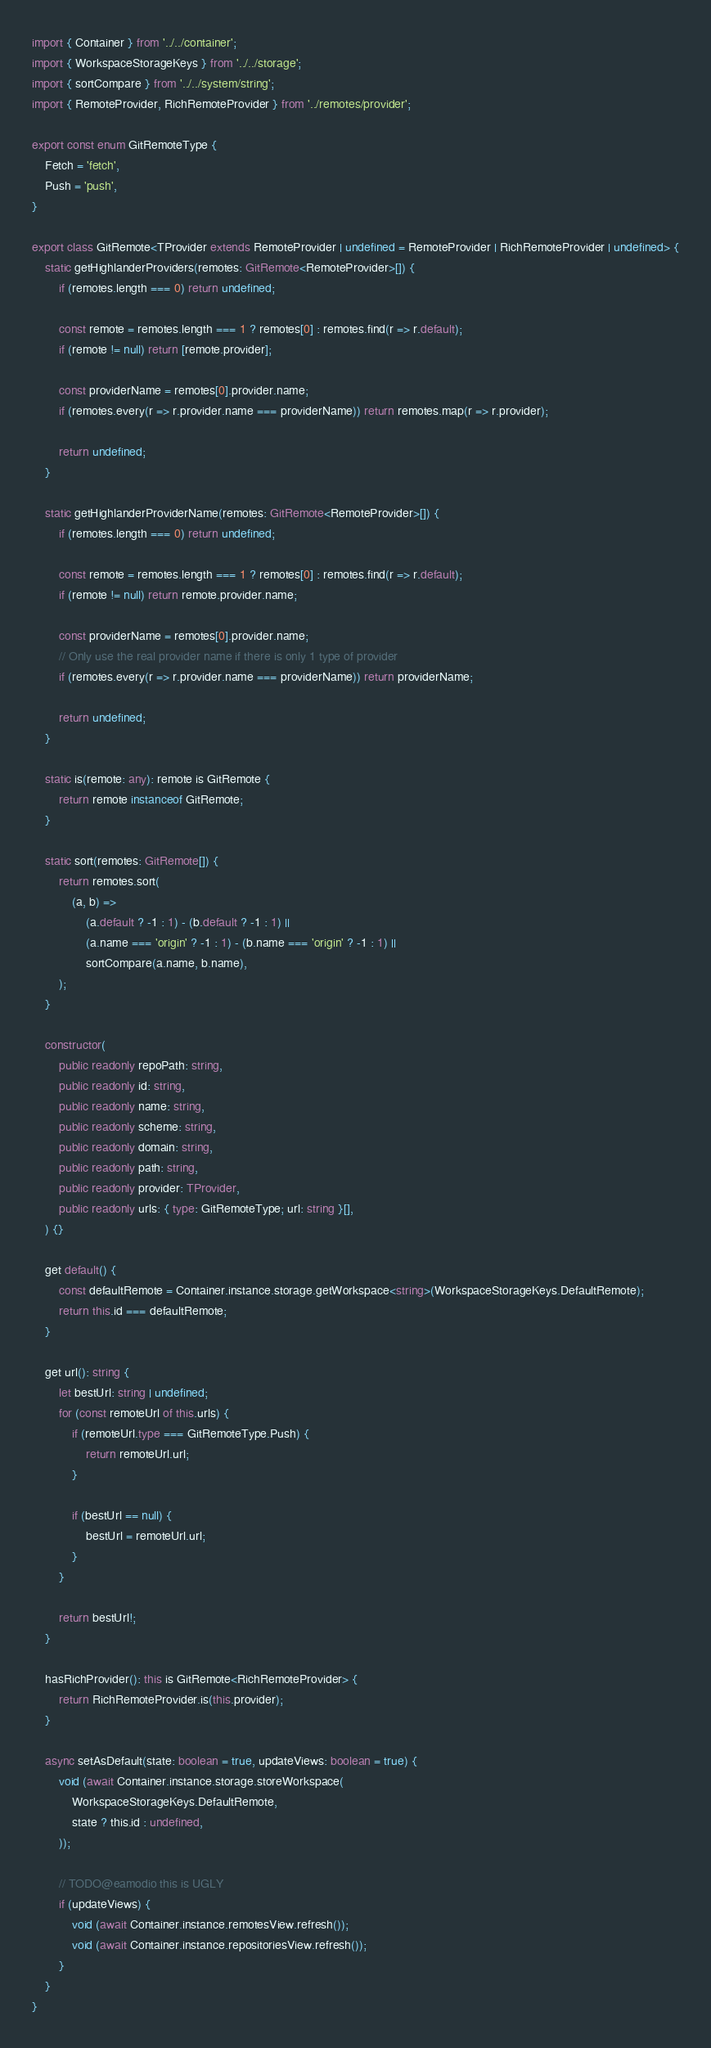Convert code to text. <code><loc_0><loc_0><loc_500><loc_500><_TypeScript_>import { Container } from '../../container';
import { WorkspaceStorageKeys } from '../../storage';
import { sortCompare } from '../../system/string';
import { RemoteProvider, RichRemoteProvider } from '../remotes/provider';

export const enum GitRemoteType {
	Fetch = 'fetch',
	Push = 'push',
}

export class GitRemote<TProvider extends RemoteProvider | undefined = RemoteProvider | RichRemoteProvider | undefined> {
	static getHighlanderProviders(remotes: GitRemote<RemoteProvider>[]) {
		if (remotes.length === 0) return undefined;

		const remote = remotes.length === 1 ? remotes[0] : remotes.find(r => r.default);
		if (remote != null) return [remote.provider];

		const providerName = remotes[0].provider.name;
		if (remotes.every(r => r.provider.name === providerName)) return remotes.map(r => r.provider);

		return undefined;
	}

	static getHighlanderProviderName(remotes: GitRemote<RemoteProvider>[]) {
		if (remotes.length === 0) return undefined;

		const remote = remotes.length === 1 ? remotes[0] : remotes.find(r => r.default);
		if (remote != null) return remote.provider.name;

		const providerName = remotes[0].provider.name;
		// Only use the real provider name if there is only 1 type of provider
		if (remotes.every(r => r.provider.name === providerName)) return providerName;

		return undefined;
	}

	static is(remote: any): remote is GitRemote {
		return remote instanceof GitRemote;
	}

	static sort(remotes: GitRemote[]) {
		return remotes.sort(
			(a, b) =>
				(a.default ? -1 : 1) - (b.default ? -1 : 1) ||
				(a.name === 'origin' ? -1 : 1) - (b.name === 'origin' ? -1 : 1) ||
				sortCompare(a.name, b.name),
		);
	}

	constructor(
		public readonly repoPath: string,
		public readonly id: string,
		public readonly name: string,
		public readonly scheme: string,
		public readonly domain: string,
		public readonly path: string,
		public readonly provider: TProvider,
		public readonly urls: { type: GitRemoteType; url: string }[],
	) {}

	get default() {
		const defaultRemote = Container.instance.storage.getWorkspace<string>(WorkspaceStorageKeys.DefaultRemote);
		return this.id === defaultRemote;
	}

	get url(): string {
		let bestUrl: string | undefined;
		for (const remoteUrl of this.urls) {
			if (remoteUrl.type === GitRemoteType.Push) {
				return remoteUrl.url;
			}

			if (bestUrl == null) {
				bestUrl = remoteUrl.url;
			}
		}

		return bestUrl!;
	}

	hasRichProvider(): this is GitRemote<RichRemoteProvider> {
		return RichRemoteProvider.is(this.provider);
	}

	async setAsDefault(state: boolean = true, updateViews: boolean = true) {
		void (await Container.instance.storage.storeWorkspace(
			WorkspaceStorageKeys.DefaultRemote,
			state ? this.id : undefined,
		));

		// TODO@eamodio this is UGLY
		if (updateViews) {
			void (await Container.instance.remotesView.refresh());
			void (await Container.instance.repositoriesView.refresh());
		}
	}
}
</code> 